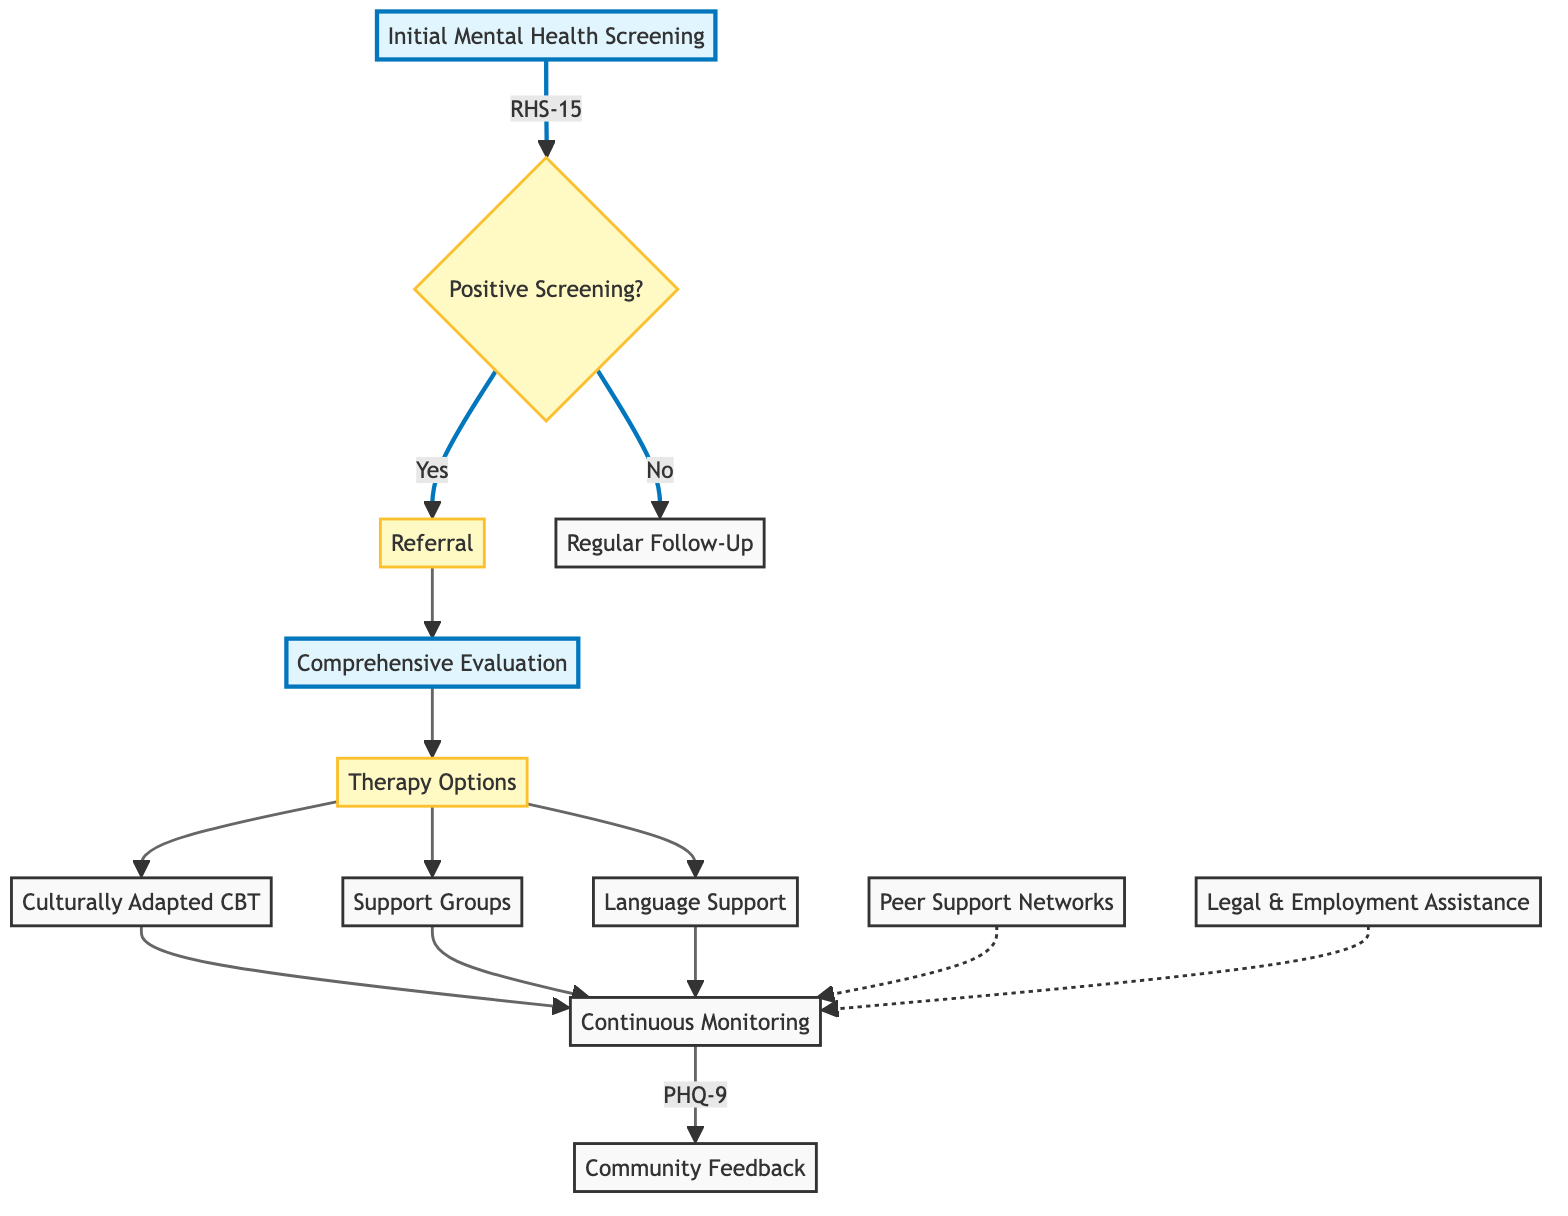What is the initial step in the pathway? The initial step in the pathway is labeled as "Initial Mental Health Screening." This is the first action taken in the process before any referrals or assessments occur.
Answer: Initial Mental Health Screening What tool is used for initial screening? The tool specified for the initial screening is the "Refugee Health Screener-15 (RHS-15)." This is mentioned directly under the initial screening node.
Answer: Refugee Health Screener-15 (RHS-15) Who performs the initial screening? The initial screening is performed by "Community Health Workers," as indicated in the diagram connected to the initial screening node.
Answer: Community Health Workers What triggers the referral? The trigger for referral occurs with a "Positive Screening Result or High Risk Indicators." This is outlined in the node that leads to the referral process.
Answer: Positive Screening Result or High Risk Indicators What follows after a comprehensive evaluation? After the comprehensive evaluation, the next step is "Therapy Options," indicating that the evaluation leads directly to available therapy methods.
Answer: Therapy Options What type of therapy is included in the pathway? The therapy options included in the pathway are "Culturally Adapted Cognitive Behavioral Therapy (CBT)," "Support Groups for Refugees," and "Language Support." This indicates various types of therapeutic interventions available for refugees.
Answer: Culturally Adapted CBT, Support Groups, Language Support How is continuous monitoring conducted? Continuous monitoring is conducted through "Regular Follow-Up Sessions," which is directly indicated as the next step after therapy options and involves a specific monitoring tool.
Answer: Regular Follow-Up Sessions What tool is used for monitoring during follow-up? The monitoring tool used during follow-up sessions is the "Patient Health Questionnaire (PHQ-9)." This tool is specifically mentioned in the follow-up monitoring section of the diagram.
Answer: Patient Health Questionnaire (PHQ-9) What additional support is provided beyond therapy? Additional support provided beyond therapy includes "Legal and Employment Assistance" and "Peer Support Networks," which are shown as connected to the monitoring phase.
Answer: Legal and Employment Assistance, Peer Support Networks 